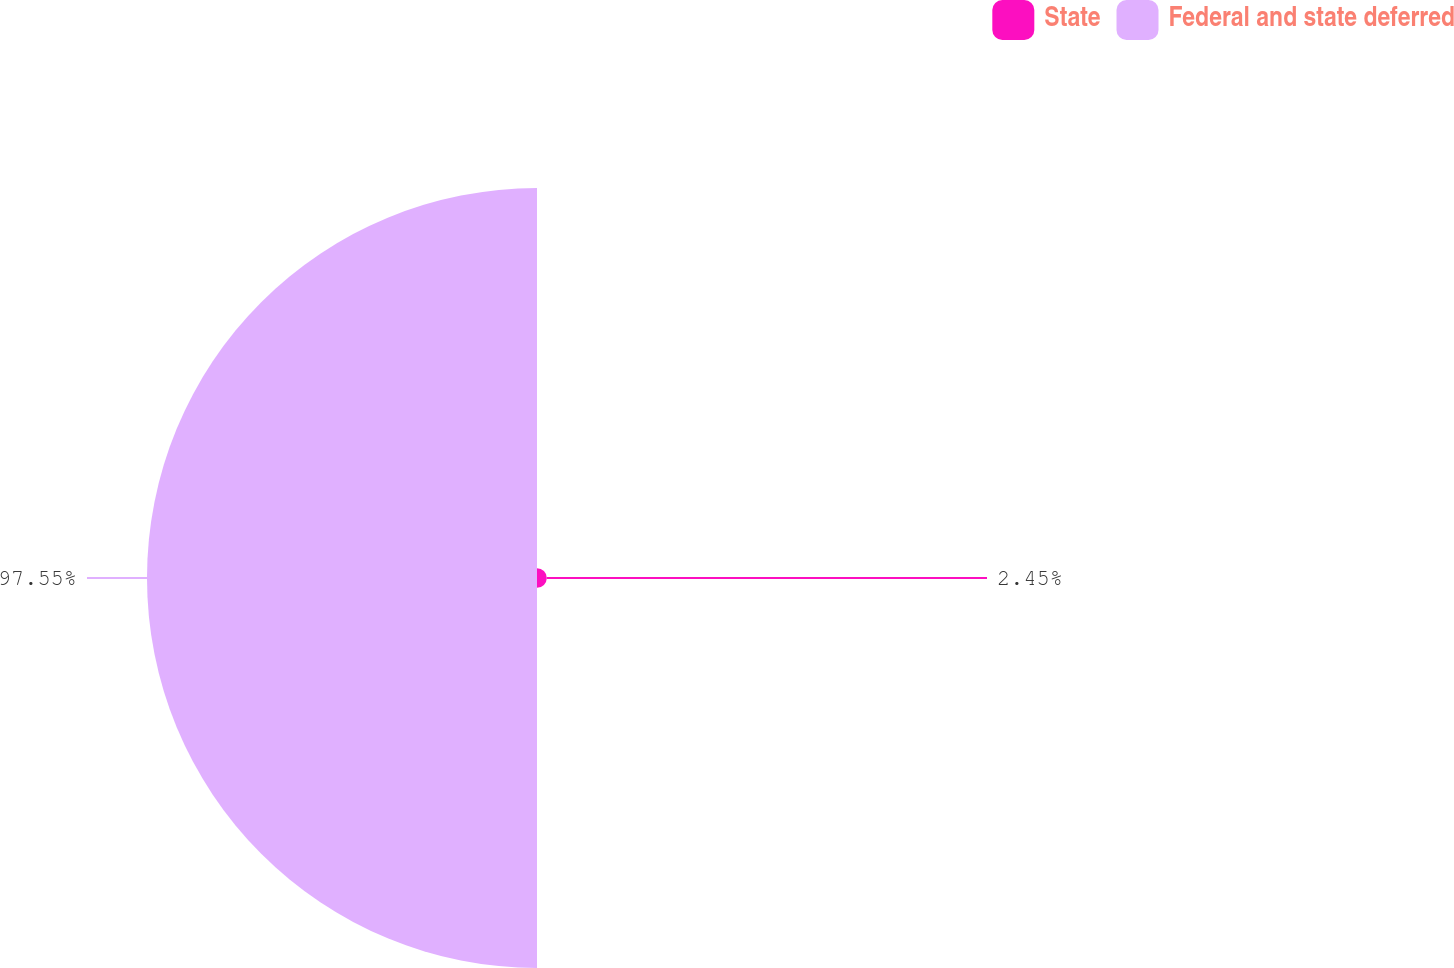Convert chart. <chart><loc_0><loc_0><loc_500><loc_500><pie_chart><fcel>State<fcel>Federal and state deferred<nl><fcel>2.45%<fcel>97.55%<nl></chart> 